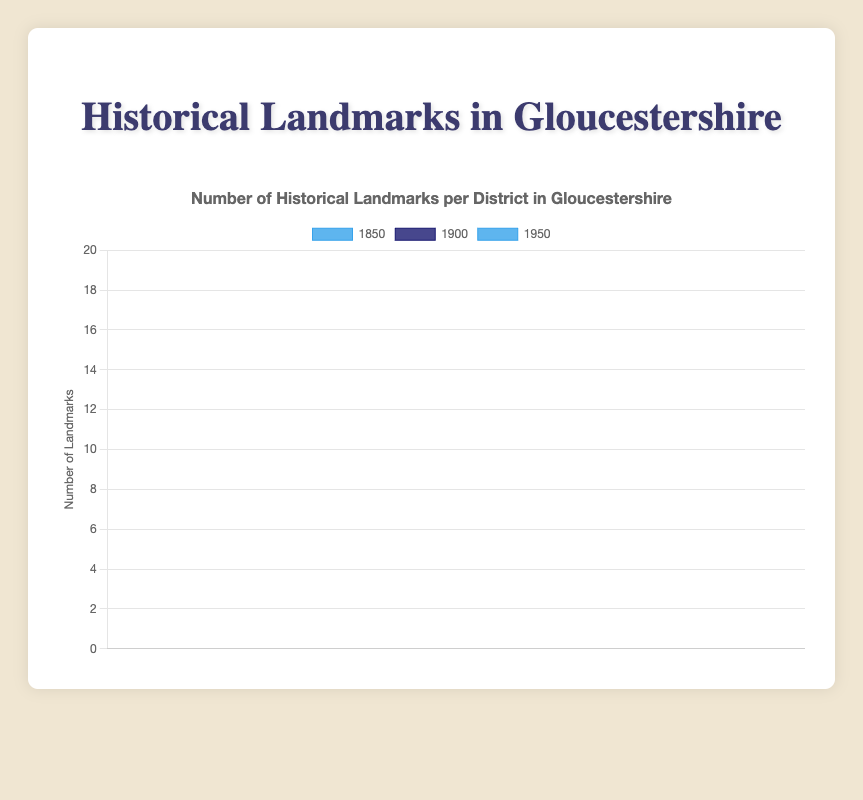How does the number of landmarks in Cheltenham in 1950 compare to the number in 1900? The bar for Cheltenham in 1950 is higher than the one in 1900 in the chart. Cheltenham has 12 landmarks in 1950 and 8 in 1900.
Answer: Cheltenham has more landmarks in 1950 Which district has the highest number of landmarks in 1950? By comparing the bar heights for 1950 across all districts, Cotswold's bar is the tallest with 16 landmarks in 1950.
Answer: Cotswold What is the total number of landmarks registered in Stroud across all years? Adding the number of landmarks in Stroud: 3 in 1850, 6 in 1900, and 9 in 1950 gives us 3 + 6 + 9 = 18.
Answer: 18 Which year has the most landmarks overall in Gloucestershire? By summing up the landmarks for each year across all districts: 1850 has 5+7+3+4+8+5 = 32, 1900 has 8+10+6+7+13+9 = 53, and 1950 has 12+14+9+11+16+12 = 74 landmarks. 1950 has the most with 74.
Answer: 1950 Are there more historical landmarks registered in Tewkesbury or Gloucester in 1850? Comparing the bars for Tewkesbury and Gloucester in 1850, Gloucester has a higher bar with 7 landmarks compared to Tewkesbury's 4.
Answer: Gloucester What is the average number of landmarks registered in the Cotswold district across the years shown? Adding Cotswold's landmarks: 8 in 1850, 13 in 1900, and 16 in 1950. The total is 8 + 13 + 16 = 37. Dividing by 3 years: 37 / 3 = 12.33 landmarks on average.
Answer: 12.33 Which district saw the highest increase in the number of landmarks from 1850 to 1950? Calculating increases from 1850 to 1950 for each district: Cheltenham: 12 - 5 = 7, Gloucester: 14 - 7 = 7, Stroud: 9 - 3 = 6, Tewkesbury: 11 - 4 = 7, Cotswold: 16 - 8 = 8, Forest of Dean: 12 - 5 = 7. Cotswold has the highest increase with 8.
Answer: Cotswold How many more landmarks were registered in Cotswold in 1950 compared to Stroud in the same year? Cotswold has 16 landmarks in 1950, Stroud has 9. The difference is 16 - 9 = 7 more landmarks.
Answer: 7 more landmarks What is the sum of landmarks registered in 1900 for Cheltenham and Forest of Dean? Cheltenham has 8 landmarks in 1900, Forest of Dean has 9. Sum is 8 + 9 = 17.
Answer: 17 